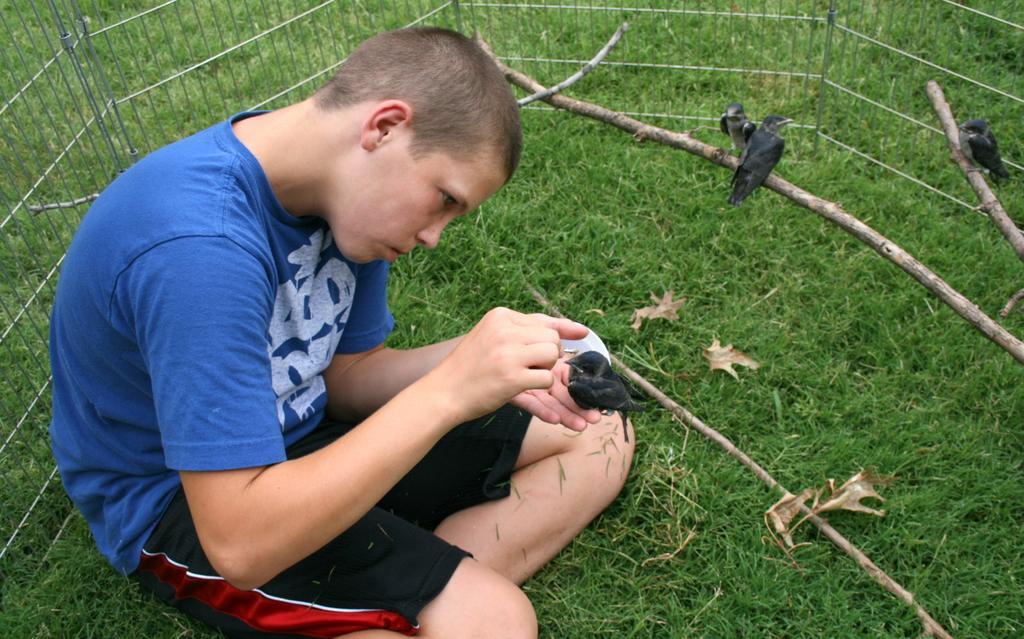Describe this image in one or two sentences. In the center of the image there is a boy holding a bird. On the top of the image we can see birds standing on the sticks. In the background there is a grill and grass. 